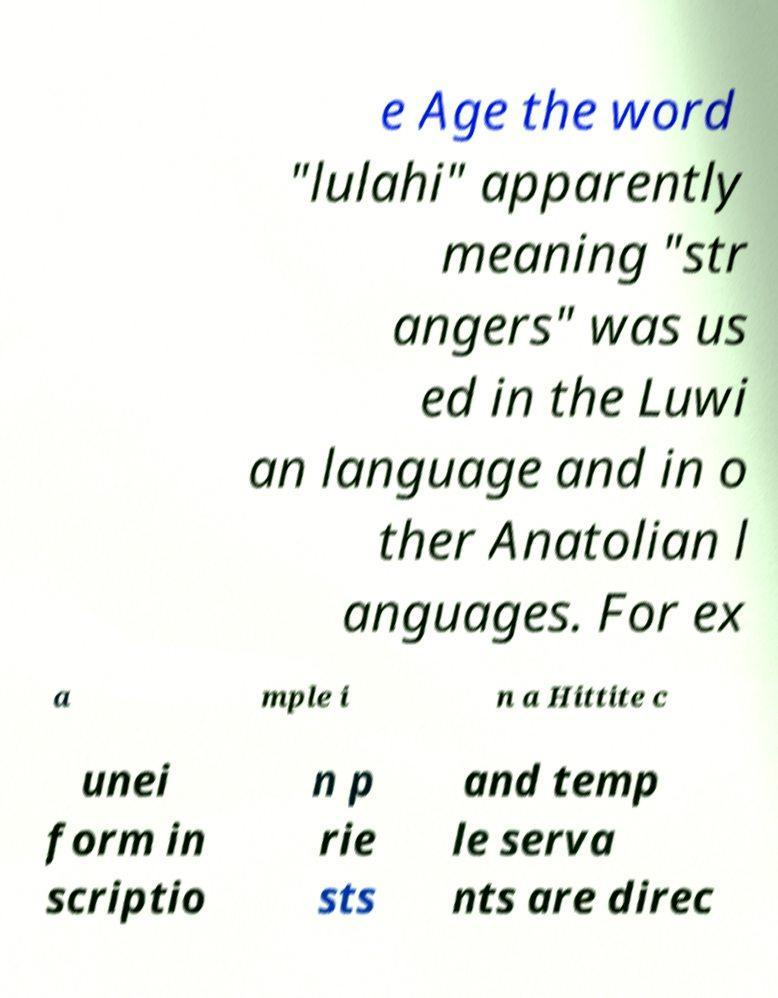Can you accurately transcribe the text from the provided image for me? e Age the word "lulahi" apparently meaning "str angers" was us ed in the Luwi an language and in o ther Anatolian l anguages. For ex a mple i n a Hittite c unei form in scriptio n p rie sts and temp le serva nts are direc 